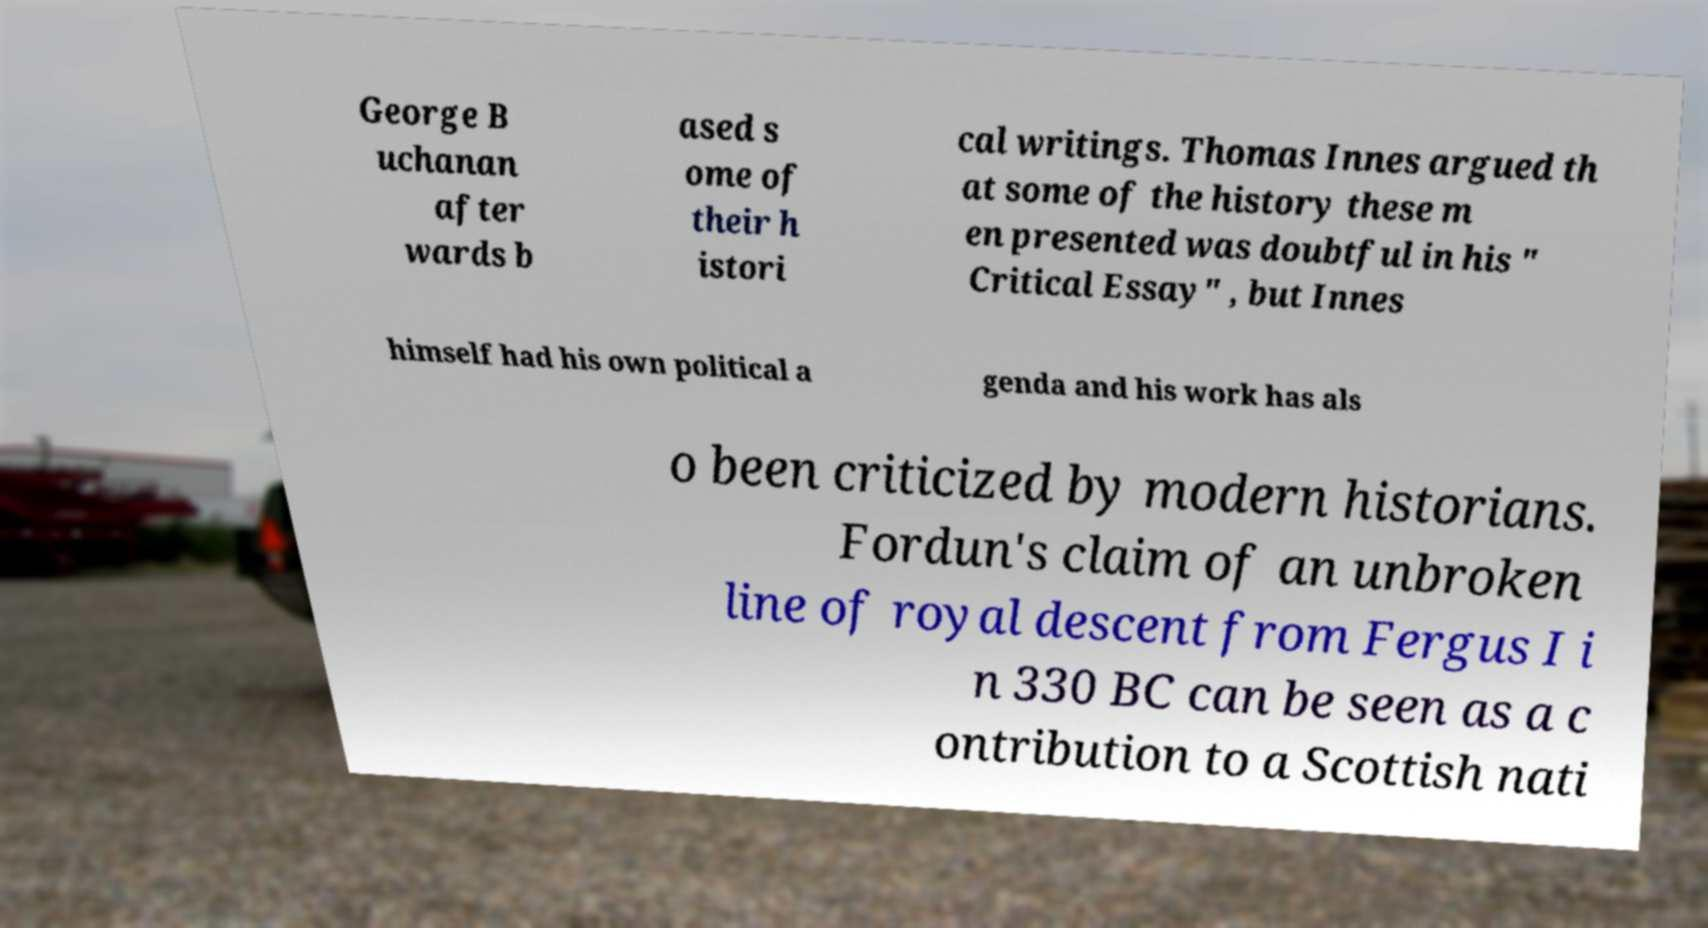There's text embedded in this image that I need extracted. Can you transcribe it verbatim? George B uchanan after wards b ased s ome of their h istori cal writings. Thomas Innes argued th at some of the history these m en presented was doubtful in his " Critical Essay" , but Innes himself had his own political a genda and his work has als o been criticized by modern historians. Fordun's claim of an unbroken line of royal descent from Fergus I i n 330 BC can be seen as a c ontribution to a Scottish nati 